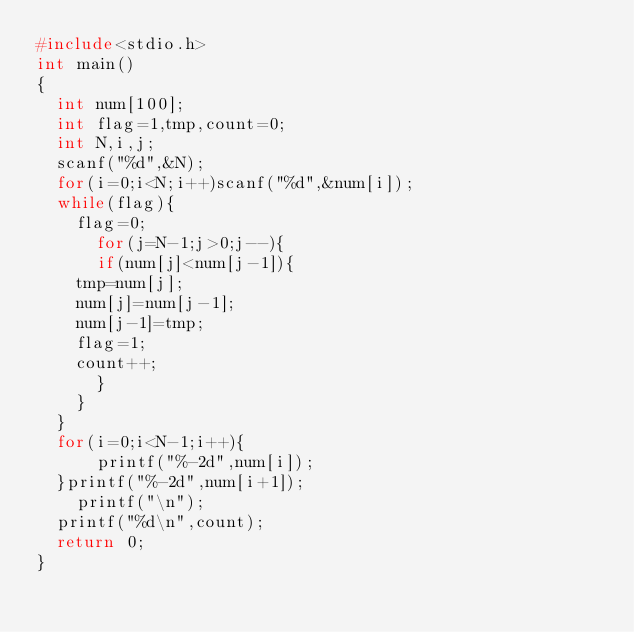<code> <loc_0><loc_0><loc_500><loc_500><_C_>#include<stdio.h>
int main()
{
  int num[100];
  int flag=1,tmp,count=0;
  int N,i,j;
  scanf("%d",&N);
  for(i=0;i<N;i++)scanf("%d",&num[i]);        
  while(flag){
    flag=0;
      for(j=N-1;j>0;j--){
      if(num[j]<num[j-1]){
	tmp=num[j];
	num[j]=num[j-1];
	num[j-1]=tmp;
	flag=1;
	count++;
	  }
    }
  }
  for(i=0;i<N-1;i++){
      printf("%-2d",num[i]);
  }printf("%-2d",num[i+1]);
    printf("\n");
  printf("%d\n",count);
  return 0;
}</code> 